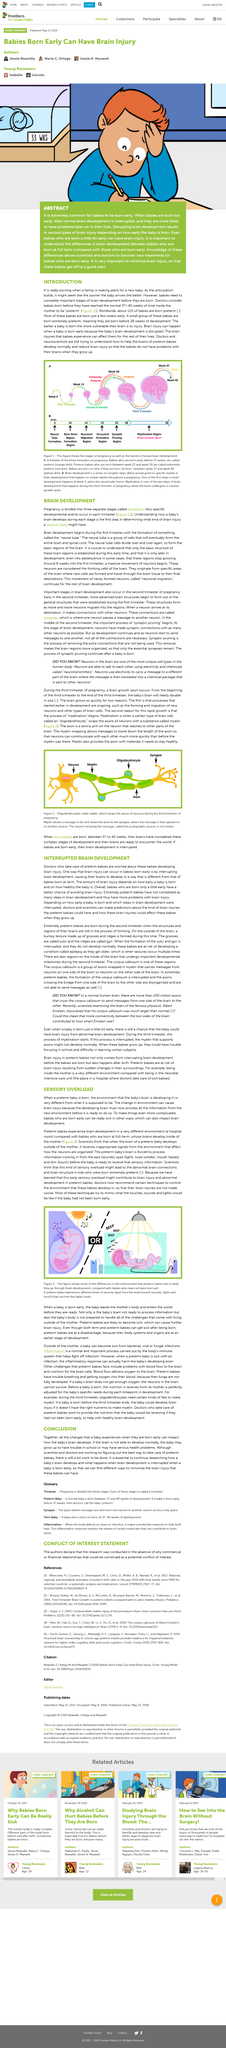Highlight a few significant elements in this photo. When a baby is born early, their normal brain development is often interrupted, which can lead to a range of potential problems later in life. Premature birth poses a significant risk of brain damage to infants. It is a common occurrence for babies to be born prematurely, with a significant number of infants arriving before the full term of gestation. Premature birth can have a significant impact on a baby's brain development, as it can lead to the baby being sick and experiencing health complications. This can cause delays in brain development, which can have long-term effects on the child's cognitive, social, and emotional development. Being born early significantly impacts the baby's brain development, which is a crucial event that has a significant impact on their overall development and future outcomes. 